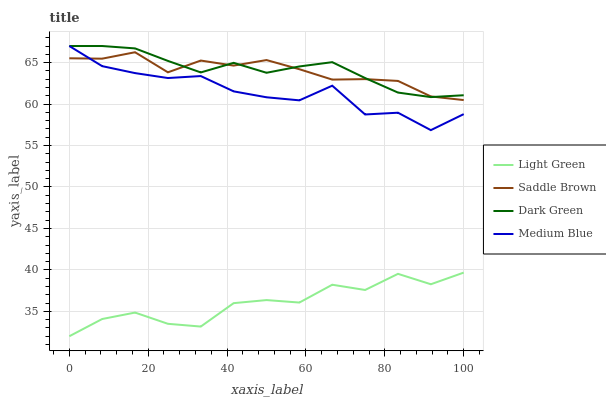Does Light Green have the minimum area under the curve?
Answer yes or no. Yes. Does Dark Green have the maximum area under the curve?
Answer yes or no. Yes. Does Saddle Brown have the minimum area under the curve?
Answer yes or no. No. Does Saddle Brown have the maximum area under the curve?
Answer yes or no. No. Is Dark Green the smoothest?
Answer yes or no. Yes. Is Light Green the roughest?
Answer yes or no. Yes. Is Saddle Brown the smoothest?
Answer yes or no. No. Is Saddle Brown the roughest?
Answer yes or no. No. Does Light Green have the lowest value?
Answer yes or no. Yes. Does Saddle Brown have the lowest value?
Answer yes or no. No. Does Dark Green have the highest value?
Answer yes or no. Yes. Does Saddle Brown have the highest value?
Answer yes or no. No. Is Light Green less than Dark Green?
Answer yes or no. Yes. Is Medium Blue greater than Light Green?
Answer yes or no. Yes. Does Medium Blue intersect Dark Green?
Answer yes or no. Yes. Is Medium Blue less than Dark Green?
Answer yes or no. No. Is Medium Blue greater than Dark Green?
Answer yes or no. No. Does Light Green intersect Dark Green?
Answer yes or no. No. 